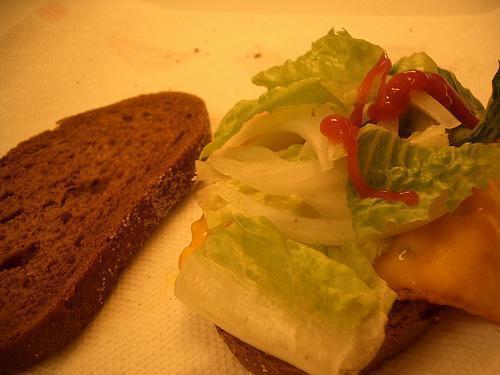How many slices of bread are there?
Give a very brief answer. 2. How many holes are in the bread?
Give a very brief answer. 2. How many slices of cheese?
Give a very brief answer. 1. 